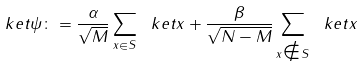<formula> <loc_0><loc_0><loc_500><loc_500>\ k e t { \psi } \colon = \frac { \alpha } { \sqrt { M } } \sum _ { x \in S } \ k e t { x } + \frac { \beta } { \sqrt { N - M } } \sum _ { x \notin S } \ k e t { x }</formula> 